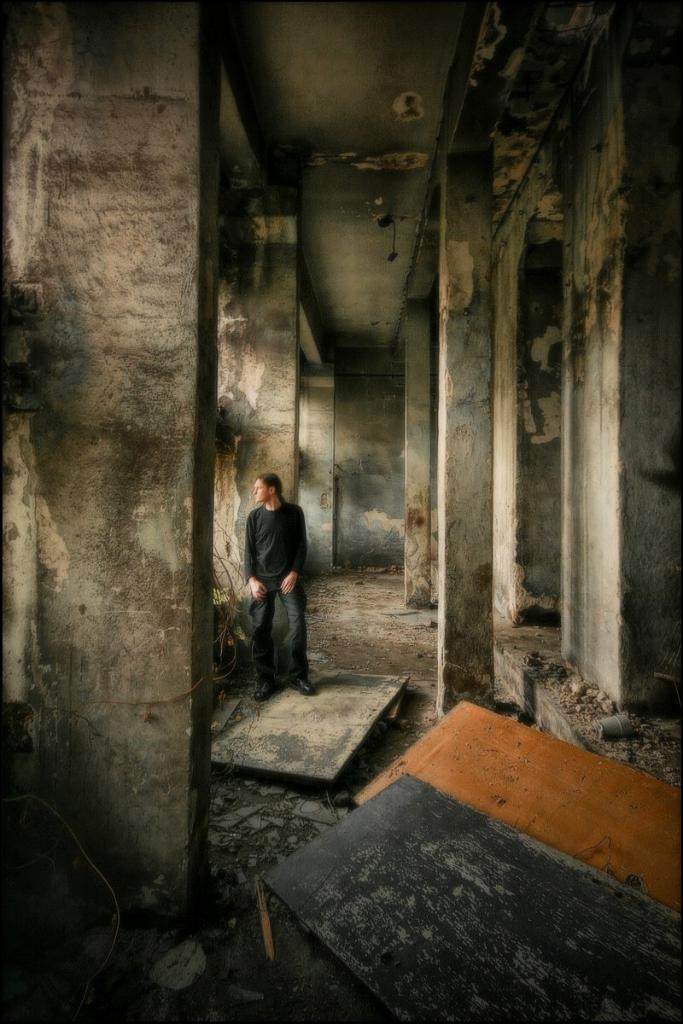What is the main subject in the image? There is a man standing in the image. What architectural features can be seen in the image? There are pillars and walls visible in the image. What type of doors are present in the image? There are wooden doors on the ground in the image. What type of plant is growing on the spot of interest in the image? There is no specific spot of interest or plant mentioned in the image. 